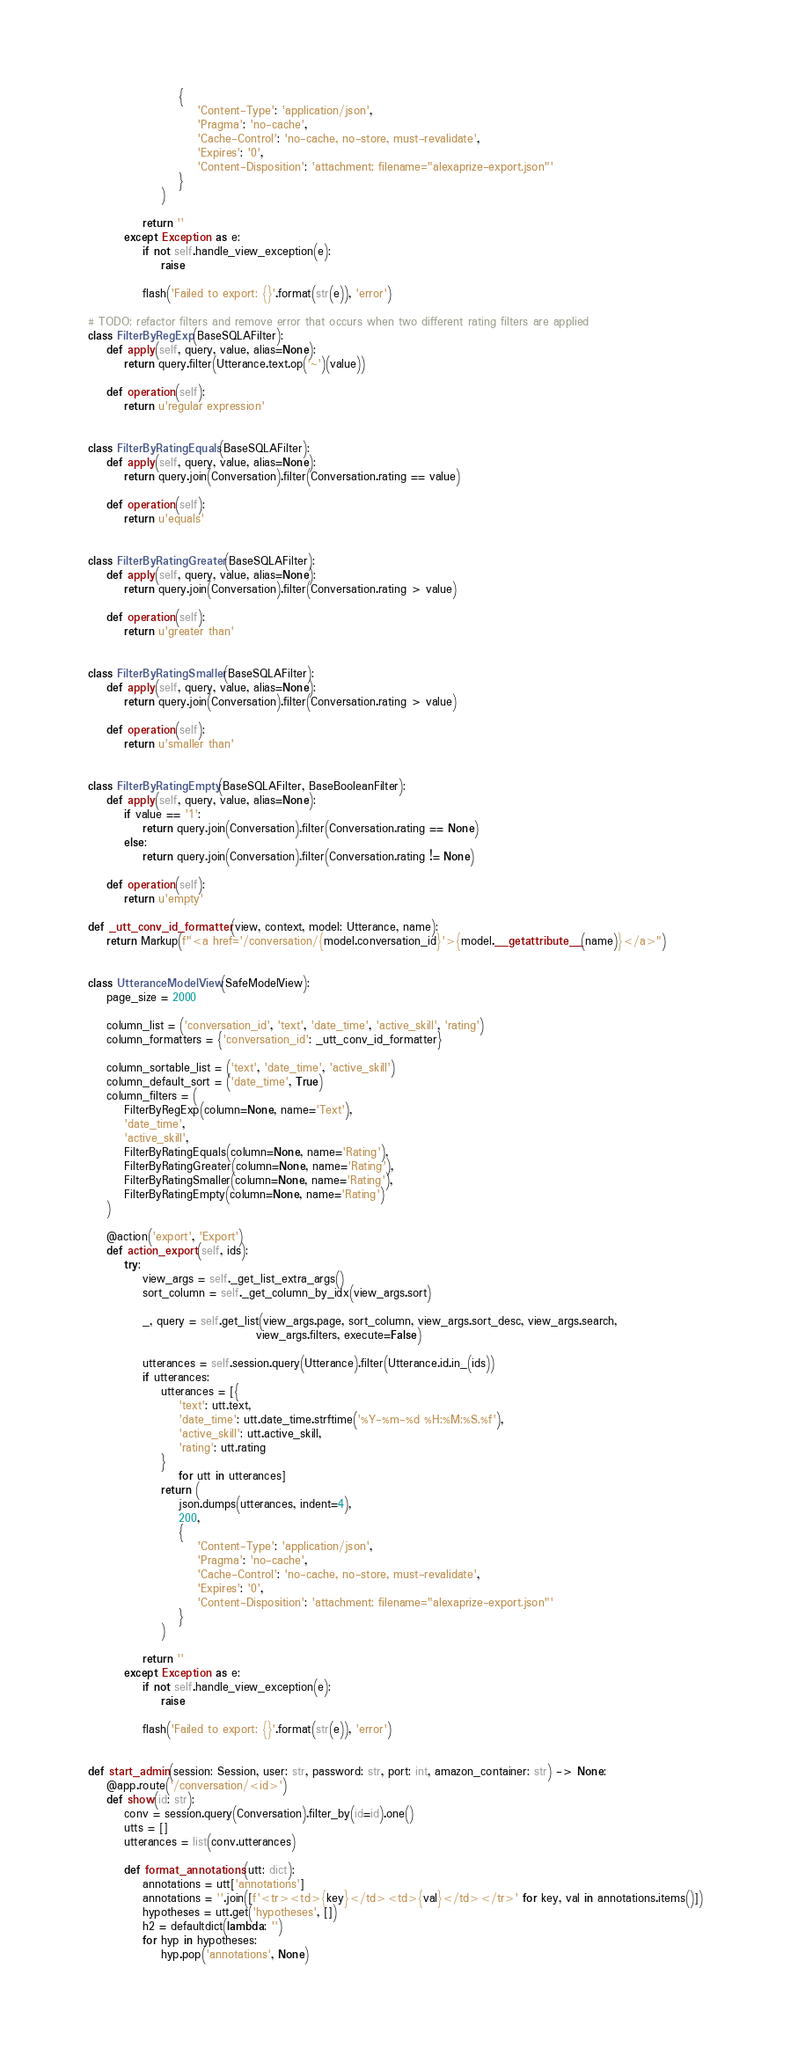<code> <loc_0><loc_0><loc_500><loc_500><_Python_>                    {
                        'Content-Type': 'application/json',
                        'Pragma': 'no-cache',
                        'Cache-Control': 'no-cache, no-store, must-revalidate',
                        'Expires': '0',
                        'Content-Disposition': 'attachment; filename="alexaprize-export.json"'
                    }
                )

            return ''
        except Exception as e:
            if not self.handle_view_exception(e):
                raise

            flash('Failed to export: {}'.format(str(e)), 'error')

# TODO: refactor filters and remove error that occurs when two different rating filters are applied
class FilterByRegExp(BaseSQLAFilter):
    def apply(self, query, value, alias=None):
        return query.filter(Utterance.text.op('~')(value))

    def operation(self):
        return u'regular expression'


class FilterByRatingEquals(BaseSQLAFilter):
    def apply(self, query, value, alias=None):
        return query.join(Conversation).filter(Conversation.rating == value)

    def operation(self):
        return u'equals'


class FilterByRatingGreater(BaseSQLAFilter):
    def apply(self, query, value, alias=None):
        return query.join(Conversation).filter(Conversation.rating > value)

    def operation(self):
        return u'greater than'


class FilterByRatingSmaller(BaseSQLAFilter):
    def apply(self, query, value, alias=None):
        return query.join(Conversation).filter(Conversation.rating > value)

    def operation(self):
        return u'smaller than'


class FilterByRatingEmpty(BaseSQLAFilter, BaseBooleanFilter):
    def apply(self, query, value, alias=None):
        if value == '1':
            return query.join(Conversation).filter(Conversation.rating == None)
        else:
            return query.join(Conversation).filter(Conversation.rating != None)

    def operation(self):
        return u'empty'

def _utt_conv_id_formatter(view, context, model: Utterance, name):
    return Markup(f"<a href='/conversation/{model.conversation_id}'>{model.__getattribute__(name)}</a>")


class UtteranceModelView(SafeModelView):
    page_size = 2000

    column_list = ('conversation_id', 'text', 'date_time', 'active_skill', 'rating')
    column_formatters = {'conversation_id': _utt_conv_id_formatter}

    column_sortable_list = ('text', 'date_time', 'active_skill')
    column_default_sort = ('date_time', True)
    column_filters = (
        FilterByRegExp(column=None, name='Text'),
        'date_time',
        'active_skill',
        FilterByRatingEquals(column=None, name='Rating'),
        FilterByRatingGreater(column=None, name='Rating'),
        FilterByRatingSmaller(column=None, name='Rating'),
        FilterByRatingEmpty(column=None, name='Rating')
    )

    @action('export', 'Export')
    def action_export(self, ids):
        try:
            view_args = self._get_list_extra_args()
            sort_column = self._get_column_by_idx(view_args.sort)

            _, query = self.get_list(view_args.page, sort_column, view_args.sort_desc, view_args.search,
                                     view_args.filters, execute=False)

            utterances = self.session.query(Utterance).filter(Utterance.id.in_(ids))
            if utterances:
                utterances = [{
                    'text': utt.text,
                    'date_time': utt.date_time.strftime('%Y-%m-%d %H:%M:%S.%f'),
                    'active_skill': utt.active_skill,
                    'rating': utt.rating
                }
                    for utt in utterances]
                return (
                    json.dumps(utterances, indent=4),
                    200,
                    {
                        'Content-Type': 'application/json',
                        'Pragma': 'no-cache',
                        'Cache-Control': 'no-cache, no-store, must-revalidate',
                        'Expires': '0',
                        'Content-Disposition': 'attachment; filename="alexaprize-export.json"'
                    }
                )

            return ''
        except Exception as e:
            if not self.handle_view_exception(e):
                raise

            flash('Failed to export: {}'.format(str(e)), 'error')


def start_admin(session: Session, user: str, password: str, port: int, amazon_container: str) -> None:
    @app.route('/conversation/<id>')
    def show(id: str):
        conv = session.query(Conversation).filter_by(id=id).one()
        utts = []
        utterances = list(conv.utterances)

        def format_annotations(utt: dict):
            annotations = utt['annotations']
            annotations = ''.join([f'<tr><td>{key}</td><td>{val}</td></tr>' for key, val in annotations.items()])
            hypotheses = utt.get('hypotheses', [])
            h2 = defaultdict(lambda: '')
            for hyp in hypotheses:
                hyp.pop('annotations', None)</code> 